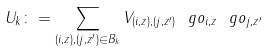Convert formula to latex. <formula><loc_0><loc_0><loc_500><loc_500>U _ { k } \colon = \sum _ { ( i , z ) , ( j , z ^ { \prime } ) \in B _ { k } } V _ { ( i , z ) , ( j , z ^ { \prime } ) } \ g o _ { i , z } \ g o _ { j , z ^ { \prime } }</formula> 